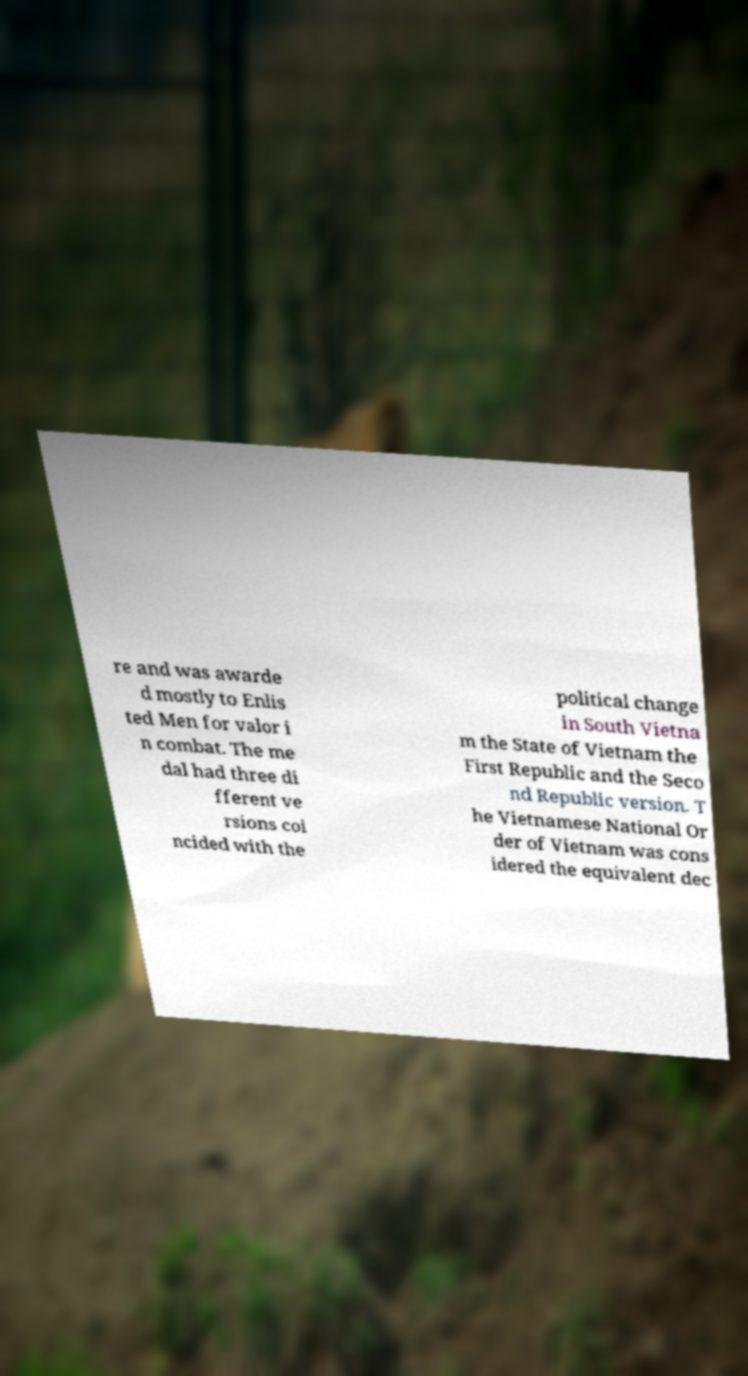What messages or text are displayed in this image? I need them in a readable, typed format. re and was awarde d mostly to Enlis ted Men for valor i n combat. The me dal had three di fferent ve rsions coi ncided with the political change in South Vietna m the State of Vietnam the First Republic and the Seco nd Republic version. T he Vietnamese National Or der of Vietnam was cons idered the equivalent dec 